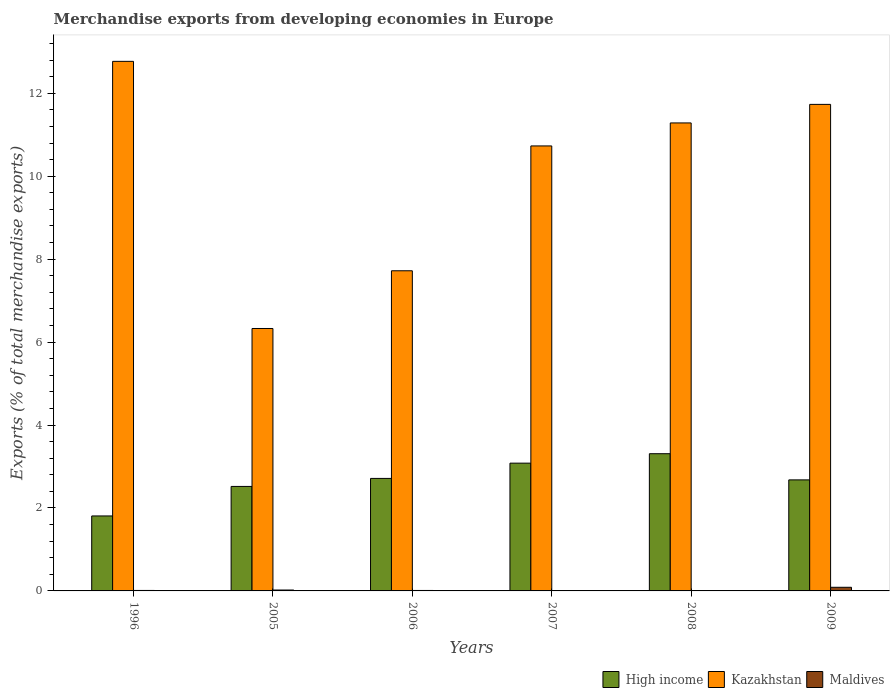Are the number of bars per tick equal to the number of legend labels?
Ensure brevity in your answer.  Yes. Are the number of bars on each tick of the X-axis equal?
Your answer should be very brief. Yes. How many bars are there on the 6th tick from the left?
Make the answer very short. 3. What is the label of the 4th group of bars from the left?
Make the answer very short. 2007. What is the percentage of total merchandise exports in Kazakhstan in 2007?
Your answer should be compact. 10.73. Across all years, what is the maximum percentage of total merchandise exports in Maldives?
Provide a short and direct response. 0.09. Across all years, what is the minimum percentage of total merchandise exports in Kazakhstan?
Your response must be concise. 6.33. What is the total percentage of total merchandise exports in Kazakhstan in the graph?
Your response must be concise. 60.56. What is the difference between the percentage of total merchandise exports in Maldives in 1996 and that in 2006?
Your answer should be compact. 0. What is the difference between the percentage of total merchandise exports in High income in 2005 and the percentage of total merchandise exports in Kazakhstan in 2006?
Your answer should be very brief. -5.2. What is the average percentage of total merchandise exports in Kazakhstan per year?
Your answer should be very brief. 10.09. In the year 2008, what is the difference between the percentage of total merchandise exports in Kazakhstan and percentage of total merchandise exports in High income?
Your answer should be compact. 7.98. What is the ratio of the percentage of total merchandise exports in Maldives in 1996 to that in 2009?
Make the answer very short. 0.13. Is the percentage of total merchandise exports in Maldives in 1996 less than that in 2006?
Provide a succinct answer. No. Is the difference between the percentage of total merchandise exports in Kazakhstan in 2008 and 2009 greater than the difference between the percentage of total merchandise exports in High income in 2008 and 2009?
Your answer should be very brief. No. What is the difference between the highest and the second highest percentage of total merchandise exports in Kazakhstan?
Keep it short and to the point. 1.04. What is the difference between the highest and the lowest percentage of total merchandise exports in High income?
Provide a short and direct response. 1.5. In how many years, is the percentage of total merchandise exports in Kazakhstan greater than the average percentage of total merchandise exports in Kazakhstan taken over all years?
Give a very brief answer. 4. What does the 1st bar from the left in 2008 represents?
Ensure brevity in your answer.  High income. What does the 1st bar from the right in 1996 represents?
Provide a succinct answer. Maldives. Are all the bars in the graph horizontal?
Ensure brevity in your answer.  No. How many years are there in the graph?
Offer a terse response. 6. What is the difference between two consecutive major ticks on the Y-axis?
Keep it short and to the point. 2. Are the values on the major ticks of Y-axis written in scientific E-notation?
Offer a very short reply. No. Where does the legend appear in the graph?
Provide a succinct answer. Bottom right. How are the legend labels stacked?
Your answer should be compact. Horizontal. What is the title of the graph?
Ensure brevity in your answer.  Merchandise exports from developing economies in Europe. What is the label or title of the X-axis?
Ensure brevity in your answer.  Years. What is the label or title of the Y-axis?
Keep it short and to the point. Exports (% of total merchandise exports). What is the Exports (% of total merchandise exports) in High income in 1996?
Your answer should be very brief. 1.81. What is the Exports (% of total merchandise exports) in Kazakhstan in 1996?
Provide a short and direct response. 12.77. What is the Exports (% of total merchandise exports) of Maldives in 1996?
Provide a succinct answer. 0.01. What is the Exports (% of total merchandise exports) in High income in 2005?
Ensure brevity in your answer.  2.52. What is the Exports (% of total merchandise exports) in Kazakhstan in 2005?
Give a very brief answer. 6.33. What is the Exports (% of total merchandise exports) of Maldives in 2005?
Ensure brevity in your answer.  0.02. What is the Exports (% of total merchandise exports) in High income in 2006?
Your answer should be compact. 2.71. What is the Exports (% of total merchandise exports) in Kazakhstan in 2006?
Make the answer very short. 7.72. What is the Exports (% of total merchandise exports) in Maldives in 2006?
Provide a short and direct response. 0.01. What is the Exports (% of total merchandise exports) of High income in 2007?
Provide a succinct answer. 3.08. What is the Exports (% of total merchandise exports) of Kazakhstan in 2007?
Your response must be concise. 10.73. What is the Exports (% of total merchandise exports) of Maldives in 2007?
Make the answer very short. 0. What is the Exports (% of total merchandise exports) of High income in 2008?
Ensure brevity in your answer.  3.31. What is the Exports (% of total merchandise exports) in Kazakhstan in 2008?
Keep it short and to the point. 11.28. What is the Exports (% of total merchandise exports) of Maldives in 2008?
Your answer should be very brief. 0. What is the Exports (% of total merchandise exports) in High income in 2009?
Offer a very short reply. 2.68. What is the Exports (% of total merchandise exports) in Kazakhstan in 2009?
Offer a terse response. 11.73. What is the Exports (% of total merchandise exports) of Maldives in 2009?
Offer a terse response. 0.09. Across all years, what is the maximum Exports (% of total merchandise exports) in High income?
Your response must be concise. 3.31. Across all years, what is the maximum Exports (% of total merchandise exports) of Kazakhstan?
Your answer should be compact. 12.77. Across all years, what is the maximum Exports (% of total merchandise exports) in Maldives?
Ensure brevity in your answer.  0.09. Across all years, what is the minimum Exports (% of total merchandise exports) in High income?
Keep it short and to the point. 1.81. Across all years, what is the minimum Exports (% of total merchandise exports) in Kazakhstan?
Give a very brief answer. 6.33. Across all years, what is the minimum Exports (% of total merchandise exports) in Maldives?
Provide a short and direct response. 0. What is the total Exports (% of total merchandise exports) of High income in the graph?
Your answer should be compact. 16.11. What is the total Exports (% of total merchandise exports) of Kazakhstan in the graph?
Provide a succinct answer. 60.56. What is the total Exports (% of total merchandise exports) in Maldives in the graph?
Provide a short and direct response. 0.13. What is the difference between the Exports (% of total merchandise exports) in High income in 1996 and that in 2005?
Provide a short and direct response. -0.71. What is the difference between the Exports (% of total merchandise exports) in Kazakhstan in 1996 and that in 2005?
Ensure brevity in your answer.  6.44. What is the difference between the Exports (% of total merchandise exports) of Maldives in 1996 and that in 2005?
Your response must be concise. -0.01. What is the difference between the Exports (% of total merchandise exports) in High income in 1996 and that in 2006?
Give a very brief answer. -0.9. What is the difference between the Exports (% of total merchandise exports) of Kazakhstan in 1996 and that in 2006?
Provide a succinct answer. 5.05. What is the difference between the Exports (% of total merchandise exports) of Maldives in 1996 and that in 2006?
Provide a short and direct response. 0. What is the difference between the Exports (% of total merchandise exports) in High income in 1996 and that in 2007?
Your answer should be very brief. -1.27. What is the difference between the Exports (% of total merchandise exports) of Kazakhstan in 1996 and that in 2007?
Ensure brevity in your answer.  2.04. What is the difference between the Exports (% of total merchandise exports) of Maldives in 1996 and that in 2007?
Your response must be concise. 0.01. What is the difference between the Exports (% of total merchandise exports) in High income in 1996 and that in 2008?
Your answer should be compact. -1.5. What is the difference between the Exports (% of total merchandise exports) of Kazakhstan in 1996 and that in 2008?
Provide a short and direct response. 1.48. What is the difference between the Exports (% of total merchandise exports) of Maldives in 1996 and that in 2008?
Your response must be concise. 0.01. What is the difference between the Exports (% of total merchandise exports) in High income in 1996 and that in 2009?
Ensure brevity in your answer.  -0.87. What is the difference between the Exports (% of total merchandise exports) in Kazakhstan in 1996 and that in 2009?
Offer a very short reply. 1.04. What is the difference between the Exports (% of total merchandise exports) of Maldives in 1996 and that in 2009?
Provide a succinct answer. -0.08. What is the difference between the Exports (% of total merchandise exports) of High income in 2005 and that in 2006?
Provide a succinct answer. -0.19. What is the difference between the Exports (% of total merchandise exports) in Kazakhstan in 2005 and that in 2006?
Offer a terse response. -1.39. What is the difference between the Exports (% of total merchandise exports) of Maldives in 2005 and that in 2006?
Offer a terse response. 0.01. What is the difference between the Exports (% of total merchandise exports) of High income in 2005 and that in 2007?
Provide a succinct answer. -0.56. What is the difference between the Exports (% of total merchandise exports) in Kazakhstan in 2005 and that in 2007?
Your response must be concise. -4.4. What is the difference between the Exports (% of total merchandise exports) in Maldives in 2005 and that in 2007?
Your answer should be compact. 0.02. What is the difference between the Exports (% of total merchandise exports) of High income in 2005 and that in 2008?
Ensure brevity in your answer.  -0.79. What is the difference between the Exports (% of total merchandise exports) in Kazakhstan in 2005 and that in 2008?
Give a very brief answer. -4.96. What is the difference between the Exports (% of total merchandise exports) of Maldives in 2005 and that in 2008?
Offer a terse response. 0.02. What is the difference between the Exports (% of total merchandise exports) of High income in 2005 and that in 2009?
Your response must be concise. -0.16. What is the difference between the Exports (% of total merchandise exports) of Kazakhstan in 2005 and that in 2009?
Your answer should be very brief. -5.4. What is the difference between the Exports (% of total merchandise exports) of Maldives in 2005 and that in 2009?
Your answer should be very brief. -0.07. What is the difference between the Exports (% of total merchandise exports) in High income in 2006 and that in 2007?
Ensure brevity in your answer.  -0.37. What is the difference between the Exports (% of total merchandise exports) of Kazakhstan in 2006 and that in 2007?
Give a very brief answer. -3.01. What is the difference between the Exports (% of total merchandise exports) of Maldives in 2006 and that in 2007?
Make the answer very short. 0.01. What is the difference between the Exports (% of total merchandise exports) of High income in 2006 and that in 2008?
Give a very brief answer. -0.6. What is the difference between the Exports (% of total merchandise exports) of Kazakhstan in 2006 and that in 2008?
Provide a short and direct response. -3.56. What is the difference between the Exports (% of total merchandise exports) in Maldives in 2006 and that in 2008?
Make the answer very short. 0.01. What is the difference between the Exports (% of total merchandise exports) of High income in 2006 and that in 2009?
Make the answer very short. 0.04. What is the difference between the Exports (% of total merchandise exports) in Kazakhstan in 2006 and that in 2009?
Keep it short and to the point. -4.01. What is the difference between the Exports (% of total merchandise exports) in Maldives in 2006 and that in 2009?
Your response must be concise. -0.08. What is the difference between the Exports (% of total merchandise exports) in High income in 2007 and that in 2008?
Your response must be concise. -0.23. What is the difference between the Exports (% of total merchandise exports) in Kazakhstan in 2007 and that in 2008?
Make the answer very short. -0.55. What is the difference between the Exports (% of total merchandise exports) of Maldives in 2007 and that in 2008?
Offer a very short reply. 0. What is the difference between the Exports (% of total merchandise exports) of High income in 2007 and that in 2009?
Your answer should be very brief. 0.4. What is the difference between the Exports (% of total merchandise exports) of Kazakhstan in 2007 and that in 2009?
Give a very brief answer. -1. What is the difference between the Exports (% of total merchandise exports) of Maldives in 2007 and that in 2009?
Your response must be concise. -0.09. What is the difference between the Exports (% of total merchandise exports) of High income in 2008 and that in 2009?
Your response must be concise. 0.63. What is the difference between the Exports (% of total merchandise exports) of Kazakhstan in 2008 and that in 2009?
Give a very brief answer. -0.45. What is the difference between the Exports (% of total merchandise exports) of Maldives in 2008 and that in 2009?
Provide a short and direct response. -0.09. What is the difference between the Exports (% of total merchandise exports) in High income in 1996 and the Exports (% of total merchandise exports) in Kazakhstan in 2005?
Offer a very short reply. -4.52. What is the difference between the Exports (% of total merchandise exports) of High income in 1996 and the Exports (% of total merchandise exports) of Maldives in 2005?
Your response must be concise. 1.79. What is the difference between the Exports (% of total merchandise exports) of Kazakhstan in 1996 and the Exports (% of total merchandise exports) of Maldives in 2005?
Keep it short and to the point. 12.75. What is the difference between the Exports (% of total merchandise exports) in High income in 1996 and the Exports (% of total merchandise exports) in Kazakhstan in 2006?
Your answer should be compact. -5.91. What is the difference between the Exports (% of total merchandise exports) of High income in 1996 and the Exports (% of total merchandise exports) of Maldives in 2006?
Offer a very short reply. 1.8. What is the difference between the Exports (% of total merchandise exports) in Kazakhstan in 1996 and the Exports (% of total merchandise exports) in Maldives in 2006?
Make the answer very short. 12.76. What is the difference between the Exports (% of total merchandise exports) in High income in 1996 and the Exports (% of total merchandise exports) in Kazakhstan in 2007?
Your answer should be very brief. -8.92. What is the difference between the Exports (% of total merchandise exports) of High income in 1996 and the Exports (% of total merchandise exports) of Maldives in 2007?
Provide a succinct answer. 1.81. What is the difference between the Exports (% of total merchandise exports) in Kazakhstan in 1996 and the Exports (% of total merchandise exports) in Maldives in 2007?
Provide a succinct answer. 12.77. What is the difference between the Exports (% of total merchandise exports) of High income in 1996 and the Exports (% of total merchandise exports) of Kazakhstan in 2008?
Your answer should be compact. -9.48. What is the difference between the Exports (% of total merchandise exports) of High income in 1996 and the Exports (% of total merchandise exports) of Maldives in 2008?
Ensure brevity in your answer.  1.81. What is the difference between the Exports (% of total merchandise exports) in Kazakhstan in 1996 and the Exports (% of total merchandise exports) in Maldives in 2008?
Make the answer very short. 12.77. What is the difference between the Exports (% of total merchandise exports) in High income in 1996 and the Exports (% of total merchandise exports) in Kazakhstan in 2009?
Your answer should be very brief. -9.92. What is the difference between the Exports (% of total merchandise exports) of High income in 1996 and the Exports (% of total merchandise exports) of Maldives in 2009?
Provide a short and direct response. 1.72. What is the difference between the Exports (% of total merchandise exports) in Kazakhstan in 1996 and the Exports (% of total merchandise exports) in Maldives in 2009?
Provide a succinct answer. 12.68. What is the difference between the Exports (% of total merchandise exports) in High income in 2005 and the Exports (% of total merchandise exports) in Kazakhstan in 2006?
Your answer should be compact. -5.2. What is the difference between the Exports (% of total merchandise exports) in High income in 2005 and the Exports (% of total merchandise exports) in Maldives in 2006?
Offer a very short reply. 2.51. What is the difference between the Exports (% of total merchandise exports) of Kazakhstan in 2005 and the Exports (% of total merchandise exports) of Maldives in 2006?
Offer a very short reply. 6.32. What is the difference between the Exports (% of total merchandise exports) of High income in 2005 and the Exports (% of total merchandise exports) of Kazakhstan in 2007?
Provide a short and direct response. -8.21. What is the difference between the Exports (% of total merchandise exports) of High income in 2005 and the Exports (% of total merchandise exports) of Maldives in 2007?
Provide a succinct answer. 2.52. What is the difference between the Exports (% of total merchandise exports) of Kazakhstan in 2005 and the Exports (% of total merchandise exports) of Maldives in 2007?
Offer a terse response. 6.33. What is the difference between the Exports (% of total merchandise exports) of High income in 2005 and the Exports (% of total merchandise exports) of Kazakhstan in 2008?
Provide a succinct answer. -8.76. What is the difference between the Exports (% of total merchandise exports) in High income in 2005 and the Exports (% of total merchandise exports) in Maldives in 2008?
Your answer should be very brief. 2.52. What is the difference between the Exports (% of total merchandise exports) of Kazakhstan in 2005 and the Exports (% of total merchandise exports) of Maldives in 2008?
Your answer should be compact. 6.33. What is the difference between the Exports (% of total merchandise exports) of High income in 2005 and the Exports (% of total merchandise exports) of Kazakhstan in 2009?
Give a very brief answer. -9.21. What is the difference between the Exports (% of total merchandise exports) of High income in 2005 and the Exports (% of total merchandise exports) of Maldives in 2009?
Keep it short and to the point. 2.43. What is the difference between the Exports (% of total merchandise exports) in Kazakhstan in 2005 and the Exports (% of total merchandise exports) in Maldives in 2009?
Your answer should be very brief. 6.24. What is the difference between the Exports (% of total merchandise exports) of High income in 2006 and the Exports (% of total merchandise exports) of Kazakhstan in 2007?
Your answer should be very brief. -8.02. What is the difference between the Exports (% of total merchandise exports) of High income in 2006 and the Exports (% of total merchandise exports) of Maldives in 2007?
Your response must be concise. 2.71. What is the difference between the Exports (% of total merchandise exports) in Kazakhstan in 2006 and the Exports (% of total merchandise exports) in Maldives in 2007?
Offer a very short reply. 7.72. What is the difference between the Exports (% of total merchandise exports) in High income in 2006 and the Exports (% of total merchandise exports) in Kazakhstan in 2008?
Keep it short and to the point. -8.57. What is the difference between the Exports (% of total merchandise exports) of High income in 2006 and the Exports (% of total merchandise exports) of Maldives in 2008?
Offer a terse response. 2.71. What is the difference between the Exports (% of total merchandise exports) of Kazakhstan in 2006 and the Exports (% of total merchandise exports) of Maldives in 2008?
Provide a short and direct response. 7.72. What is the difference between the Exports (% of total merchandise exports) of High income in 2006 and the Exports (% of total merchandise exports) of Kazakhstan in 2009?
Your response must be concise. -9.02. What is the difference between the Exports (% of total merchandise exports) of High income in 2006 and the Exports (% of total merchandise exports) of Maldives in 2009?
Provide a succinct answer. 2.62. What is the difference between the Exports (% of total merchandise exports) in Kazakhstan in 2006 and the Exports (% of total merchandise exports) in Maldives in 2009?
Your answer should be very brief. 7.63. What is the difference between the Exports (% of total merchandise exports) of High income in 2007 and the Exports (% of total merchandise exports) of Kazakhstan in 2008?
Your answer should be very brief. -8.2. What is the difference between the Exports (% of total merchandise exports) in High income in 2007 and the Exports (% of total merchandise exports) in Maldives in 2008?
Your answer should be compact. 3.08. What is the difference between the Exports (% of total merchandise exports) of Kazakhstan in 2007 and the Exports (% of total merchandise exports) of Maldives in 2008?
Your response must be concise. 10.73. What is the difference between the Exports (% of total merchandise exports) of High income in 2007 and the Exports (% of total merchandise exports) of Kazakhstan in 2009?
Make the answer very short. -8.65. What is the difference between the Exports (% of total merchandise exports) of High income in 2007 and the Exports (% of total merchandise exports) of Maldives in 2009?
Offer a terse response. 2.99. What is the difference between the Exports (% of total merchandise exports) of Kazakhstan in 2007 and the Exports (% of total merchandise exports) of Maldives in 2009?
Your answer should be compact. 10.64. What is the difference between the Exports (% of total merchandise exports) in High income in 2008 and the Exports (% of total merchandise exports) in Kazakhstan in 2009?
Your answer should be very brief. -8.42. What is the difference between the Exports (% of total merchandise exports) of High income in 2008 and the Exports (% of total merchandise exports) of Maldives in 2009?
Give a very brief answer. 3.22. What is the difference between the Exports (% of total merchandise exports) in Kazakhstan in 2008 and the Exports (% of total merchandise exports) in Maldives in 2009?
Offer a terse response. 11.2. What is the average Exports (% of total merchandise exports) of High income per year?
Offer a very short reply. 2.68. What is the average Exports (% of total merchandise exports) in Kazakhstan per year?
Your response must be concise. 10.09. What is the average Exports (% of total merchandise exports) of Maldives per year?
Your answer should be compact. 0.02. In the year 1996, what is the difference between the Exports (% of total merchandise exports) of High income and Exports (% of total merchandise exports) of Kazakhstan?
Provide a succinct answer. -10.96. In the year 1996, what is the difference between the Exports (% of total merchandise exports) of High income and Exports (% of total merchandise exports) of Maldives?
Ensure brevity in your answer.  1.8. In the year 1996, what is the difference between the Exports (% of total merchandise exports) in Kazakhstan and Exports (% of total merchandise exports) in Maldives?
Your answer should be compact. 12.76. In the year 2005, what is the difference between the Exports (% of total merchandise exports) of High income and Exports (% of total merchandise exports) of Kazakhstan?
Your answer should be compact. -3.81. In the year 2005, what is the difference between the Exports (% of total merchandise exports) in High income and Exports (% of total merchandise exports) in Maldives?
Offer a very short reply. 2.5. In the year 2005, what is the difference between the Exports (% of total merchandise exports) of Kazakhstan and Exports (% of total merchandise exports) of Maldives?
Provide a succinct answer. 6.31. In the year 2006, what is the difference between the Exports (% of total merchandise exports) of High income and Exports (% of total merchandise exports) of Kazakhstan?
Offer a terse response. -5.01. In the year 2006, what is the difference between the Exports (% of total merchandise exports) of High income and Exports (% of total merchandise exports) of Maldives?
Offer a very short reply. 2.7. In the year 2006, what is the difference between the Exports (% of total merchandise exports) in Kazakhstan and Exports (% of total merchandise exports) in Maldives?
Your answer should be compact. 7.71. In the year 2007, what is the difference between the Exports (% of total merchandise exports) of High income and Exports (% of total merchandise exports) of Kazakhstan?
Make the answer very short. -7.65. In the year 2007, what is the difference between the Exports (% of total merchandise exports) in High income and Exports (% of total merchandise exports) in Maldives?
Offer a terse response. 3.08. In the year 2007, what is the difference between the Exports (% of total merchandise exports) in Kazakhstan and Exports (% of total merchandise exports) in Maldives?
Offer a very short reply. 10.73. In the year 2008, what is the difference between the Exports (% of total merchandise exports) of High income and Exports (% of total merchandise exports) of Kazakhstan?
Your answer should be compact. -7.98. In the year 2008, what is the difference between the Exports (% of total merchandise exports) in High income and Exports (% of total merchandise exports) in Maldives?
Your answer should be very brief. 3.31. In the year 2008, what is the difference between the Exports (% of total merchandise exports) in Kazakhstan and Exports (% of total merchandise exports) in Maldives?
Give a very brief answer. 11.28. In the year 2009, what is the difference between the Exports (% of total merchandise exports) of High income and Exports (% of total merchandise exports) of Kazakhstan?
Provide a short and direct response. -9.05. In the year 2009, what is the difference between the Exports (% of total merchandise exports) of High income and Exports (% of total merchandise exports) of Maldives?
Your response must be concise. 2.59. In the year 2009, what is the difference between the Exports (% of total merchandise exports) in Kazakhstan and Exports (% of total merchandise exports) in Maldives?
Give a very brief answer. 11.64. What is the ratio of the Exports (% of total merchandise exports) in High income in 1996 to that in 2005?
Your answer should be very brief. 0.72. What is the ratio of the Exports (% of total merchandise exports) of Kazakhstan in 1996 to that in 2005?
Ensure brevity in your answer.  2.02. What is the ratio of the Exports (% of total merchandise exports) of Maldives in 1996 to that in 2005?
Provide a short and direct response. 0.54. What is the ratio of the Exports (% of total merchandise exports) of High income in 1996 to that in 2006?
Provide a short and direct response. 0.67. What is the ratio of the Exports (% of total merchandise exports) of Kazakhstan in 1996 to that in 2006?
Provide a succinct answer. 1.65. What is the ratio of the Exports (% of total merchandise exports) of Maldives in 1996 to that in 2006?
Your answer should be compact. 1.05. What is the ratio of the Exports (% of total merchandise exports) of High income in 1996 to that in 2007?
Offer a very short reply. 0.59. What is the ratio of the Exports (% of total merchandise exports) in Kazakhstan in 1996 to that in 2007?
Provide a short and direct response. 1.19. What is the ratio of the Exports (% of total merchandise exports) in Maldives in 1996 to that in 2007?
Offer a very short reply. 5.92. What is the ratio of the Exports (% of total merchandise exports) of High income in 1996 to that in 2008?
Your response must be concise. 0.55. What is the ratio of the Exports (% of total merchandise exports) in Kazakhstan in 1996 to that in 2008?
Keep it short and to the point. 1.13. What is the ratio of the Exports (% of total merchandise exports) of Maldives in 1996 to that in 2008?
Offer a terse response. 37.36. What is the ratio of the Exports (% of total merchandise exports) in High income in 1996 to that in 2009?
Give a very brief answer. 0.68. What is the ratio of the Exports (% of total merchandise exports) of Kazakhstan in 1996 to that in 2009?
Provide a short and direct response. 1.09. What is the ratio of the Exports (% of total merchandise exports) in Maldives in 1996 to that in 2009?
Offer a terse response. 0.13. What is the ratio of the Exports (% of total merchandise exports) of High income in 2005 to that in 2006?
Your answer should be very brief. 0.93. What is the ratio of the Exports (% of total merchandise exports) of Kazakhstan in 2005 to that in 2006?
Ensure brevity in your answer.  0.82. What is the ratio of the Exports (% of total merchandise exports) of Maldives in 2005 to that in 2006?
Provide a succinct answer. 1.97. What is the ratio of the Exports (% of total merchandise exports) in High income in 2005 to that in 2007?
Ensure brevity in your answer.  0.82. What is the ratio of the Exports (% of total merchandise exports) in Kazakhstan in 2005 to that in 2007?
Offer a terse response. 0.59. What is the ratio of the Exports (% of total merchandise exports) in Maldives in 2005 to that in 2007?
Provide a short and direct response. 11.04. What is the ratio of the Exports (% of total merchandise exports) of High income in 2005 to that in 2008?
Your answer should be compact. 0.76. What is the ratio of the Exports (% of total merchandise exports) of Kazakhstan in 2005 to that in 2008?
Your answer should be very brief. 0.56. What is the ratio of the Exports (% of total merchandise exports) of Maldives in 2005 to that in 2008?
Your answer should be compact. 69.69. What is the ratio of the Exports (% of total merchandise exports) in High income in 2005 to that in 2009?
Your answer should be compact. 0.94. What is the ratio of the Exports (% of total merchandise exports) of Kazakhstan in 2005 to that in 2009?
Ensure brevity in your answer.  0.54. What is the ratio of the Exports (% of total merchandise exports) in Maldives in 2005 to that in 2009?
Offer a terse response. 0.25. What is the ratio of the Exports (% of total merchandise exports) of High income in 2006 to that in 2007?
Make the answer very short. 0.88. What is the ratio of the Exports (% of total merchandise exports) in Kazakhstan in 2006 to that in 2007?
Your answer should be very brief. 0.72. What is the ratio of the Exports (% of total merchandise exports) in Maldives in 2006 to that in 2007?
Keep it short and to the point. 5.62. What is the ratio of the Exports (% of total merchandise exports) in High income in 2006 to that in 2008?
Give a very brief answer. 0.82. What is the ratio of the Exports (% of total merchandise exports) of Kazakhstan in 2006 to that in 2008?
Offer a very short reply. 0.68. What is the ratio of the Exports (% of total merchandise exports) in Maldives in 2006 to that in 2008?
Ensure brevity in your answer.  35.46. What is the ratio of the Exports (% of total merchandise exports) in High income in 2006 to that in 2009?
Ensure brevity in your answer.  1.01. What is the ratio of the Exports (% of total merchandise exports) in Kazakhstan in 2006 to that in 2009?
Provide a succinct answer. 0.66. What is the ratio of the Exports (% of total merchandise exports) of Maldives in 2006 to that in 2009?
Your answer should be very brief. 0.13. What is the ratio of the Exports (% of total merchandise exports) in High income in 2007 to that in 2008?
Keep it short and to the point. 0.93. What is the ratio of the Exports (% of total merchandise exports) of Kazakhstan in 2007 to that in 2008?
Give a very brief answer. 0.95. What is the ratio of the Exports (% of total merchandise exports) in Maldives in 2007 to that in 2008?
Your answer should be compact. 6.31. What is the ratio of the Exports (% of total merchandise exports) in High income in 2007 to that in 2009?
Your answer should be compact. 1.15. What is the ratio of the Exports (% of total merchandise exports) of Kazakhstan in 2007 to that in 2009?
Make the answer very short. 0.91. What is the ratio of the Exports (% of total merchandise exports) of Maldives in 2007 to that in 2009?
Your answer should be compact. 0.02. What is the ratio of the Exports (% of total merchandise exports) of High income in 2008 to that in 2009?
Provide a short and direct response. 1.24. What is the ratio of the Exports (% of total merchandise exports) of Kazakhstan in 2008 to that in 2009?
Your answer should be compact. 0.96. What is the ratio of the Exports (% of total merchandise exports) of Maldives in 2008 to that in 2009?
Offer a terse response. 0. What is the difference between the highest and the second highest Exports (% of total merchandise exports) in High income?
Provide a succinct answer. 0.23. What is the difference between the highest and the second highest Exports (% of total merchandise exports) of Kazakhstan?
Make the answer very short. 1.04. What is the difference between the highest and the second highest Exports (% of total merchandise exports) of Maldives?
Offer a terse response. 0.07. What is the difference between the highest and the lowest Exports (% of total merchandise exports) of High income?
Your response must be concise. 1.5. What is the difference between the highest and the lowest Exports (% of total merchandise exports) in Kazakhstan?
Your answer should be compact. 6.44. What is the difference between the highest and the lowest Exports (% of total merchandise exports) of Maldives?
Give a very brief answer. 0.09. 